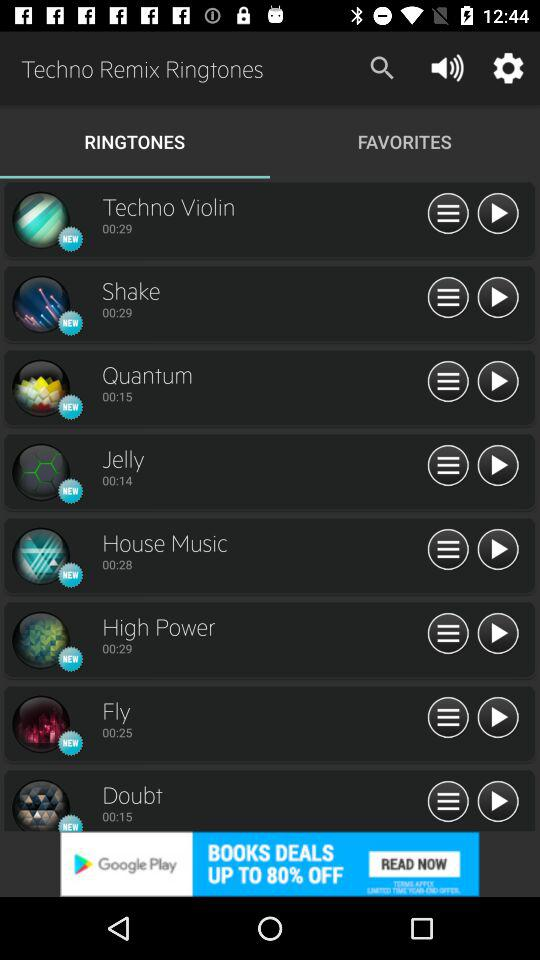Which option is selected? The selected option is "RINGTONES". 